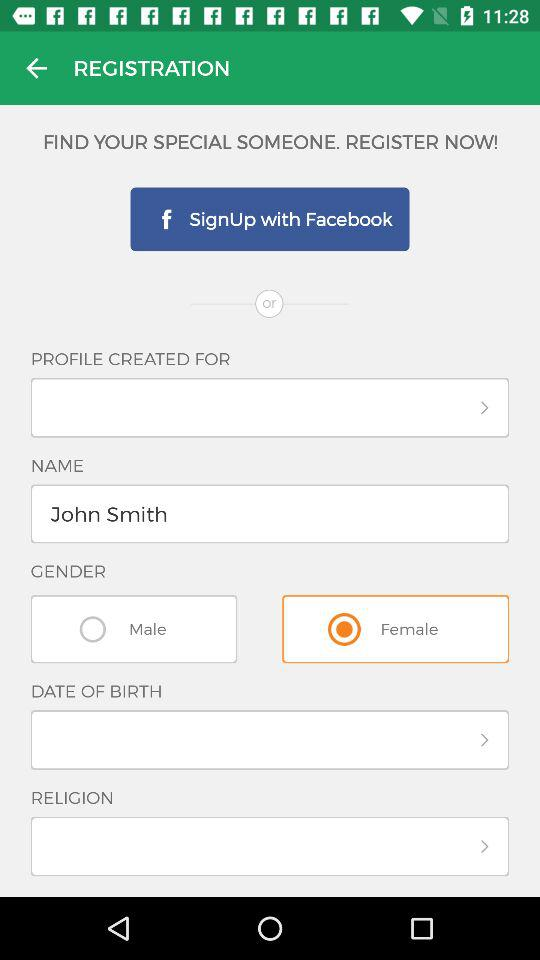What are the different options through which we can sign up? You can sign up through "Facebook". 